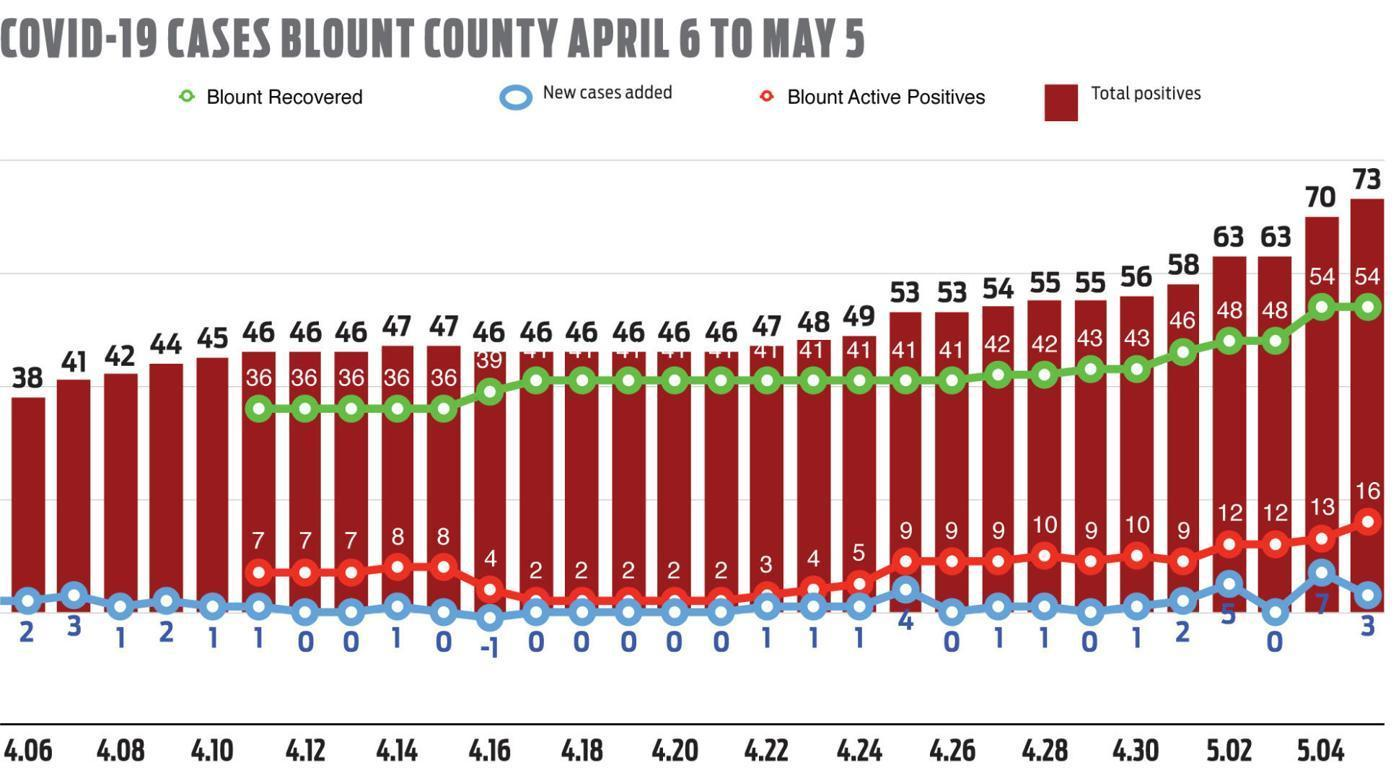What is the second highest value of Blount recovered rate?
Answer the question with a short phrase. 48 Which is the total positive count which is occurred most in all the days? 46 What is the no of active cases when total positive case is 47 for the third time? 3 What is the Blount recovered rate when total positive case is 55 for the second time? 43 How many new cases reported on the day where total positive case is 45? 1 What value of new cases has occurred in most of the days? 0 What is the highest value of new cases? 4 Which is the Blount recovered rate which has occurred most no of times? 41 